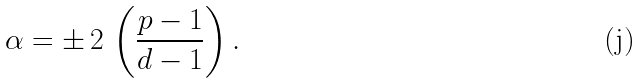Convert formula to latex. <formula><loc_0><loc_0><loc_500><loc_500>\alpha = \pm \, 2 \, \left ( \frac { p - 1 } { d - 1 } \right ) .</formula> 